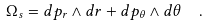<formula> <loc_0><loc_0><loc_500><loc_500>\Omega _ { s } = d p _ { r } \wedge d r + d p _ { \theta } \wedge d \theta \ \ .</formula> 